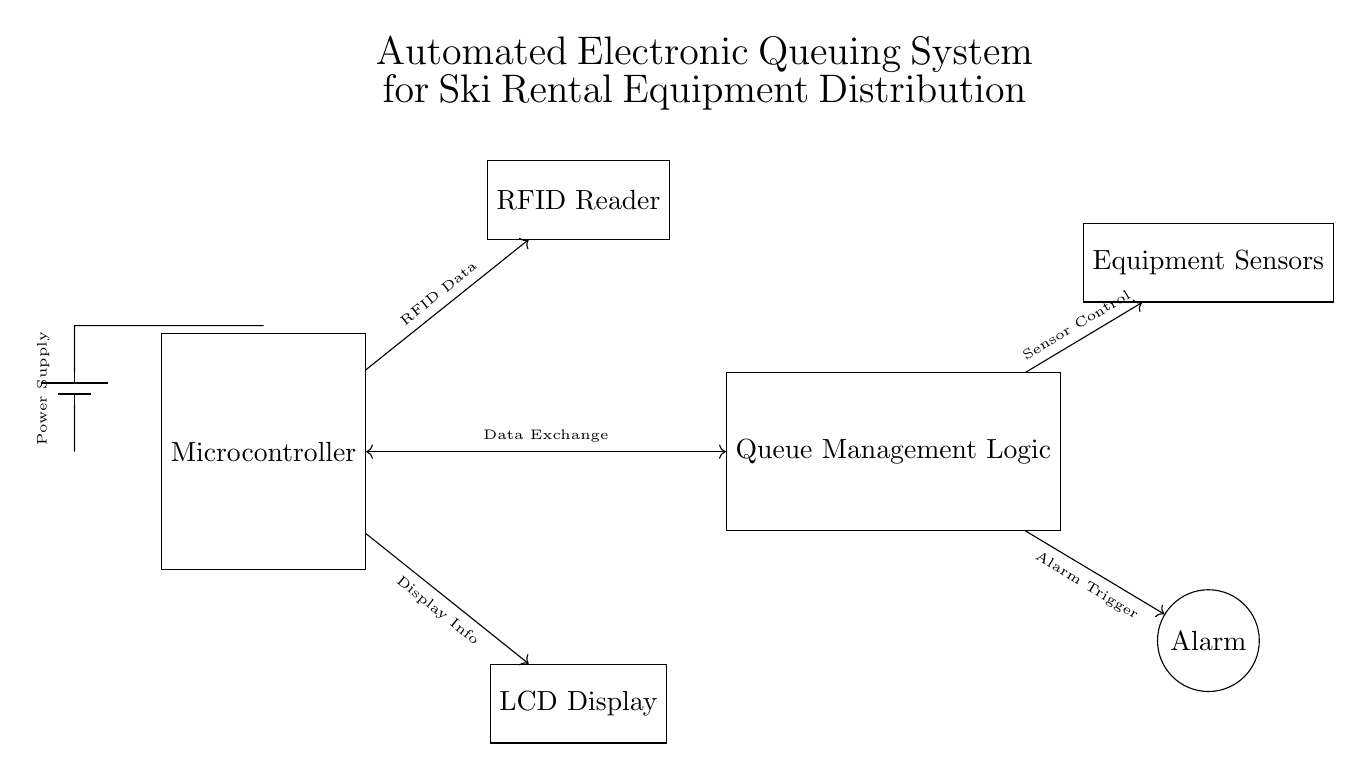What is the main component in this circuit? The main component is the microcontroller which controls the entire automated queuing system. It's central to the functionality of the circuit, managing data communication and control signals.
Answer: Microcontroller What does the RFID reader do? The RFID reader scans RFID tags associated with equipment or users, capturing relevant data to manage the queuing process for ski rentals. This function is essential for identifying and tracking rental items.
Answer: Scans tags How many output components are in the circuit? There are two output components: the LCD display and the alarm. These components provide feedback to the user regarding the equipment status and any necessary alerts.
Answer: Two Which component is responsible for managing the queue? The queue management logic is responsible for handling the queuing process, coordinating between the RFID data input and the equipment sensors to effectively manage rentals.
Answer: Queue Management Logic What is the purpose of the alarm in this circuit? The alarm is triggered by the queue management logic to alert users or staff about specific conditions, such as system errors, equipment availability, or maintenance needs, ensuring smooth operations.
Answer: Alerts users How does the microcontroller interact with the queue management logic? The microcontroller exchanges data with the queue management logic via a bi-directional communication link, allowing it to send and receive necessary information for processing the queue.
Answer: Data exchange What powers the entire circuit? The circuit is powered by a battery which supplies the necessary voltage to all components, ensuring they operate correctly and effectively within the system.
Answer: Battery 